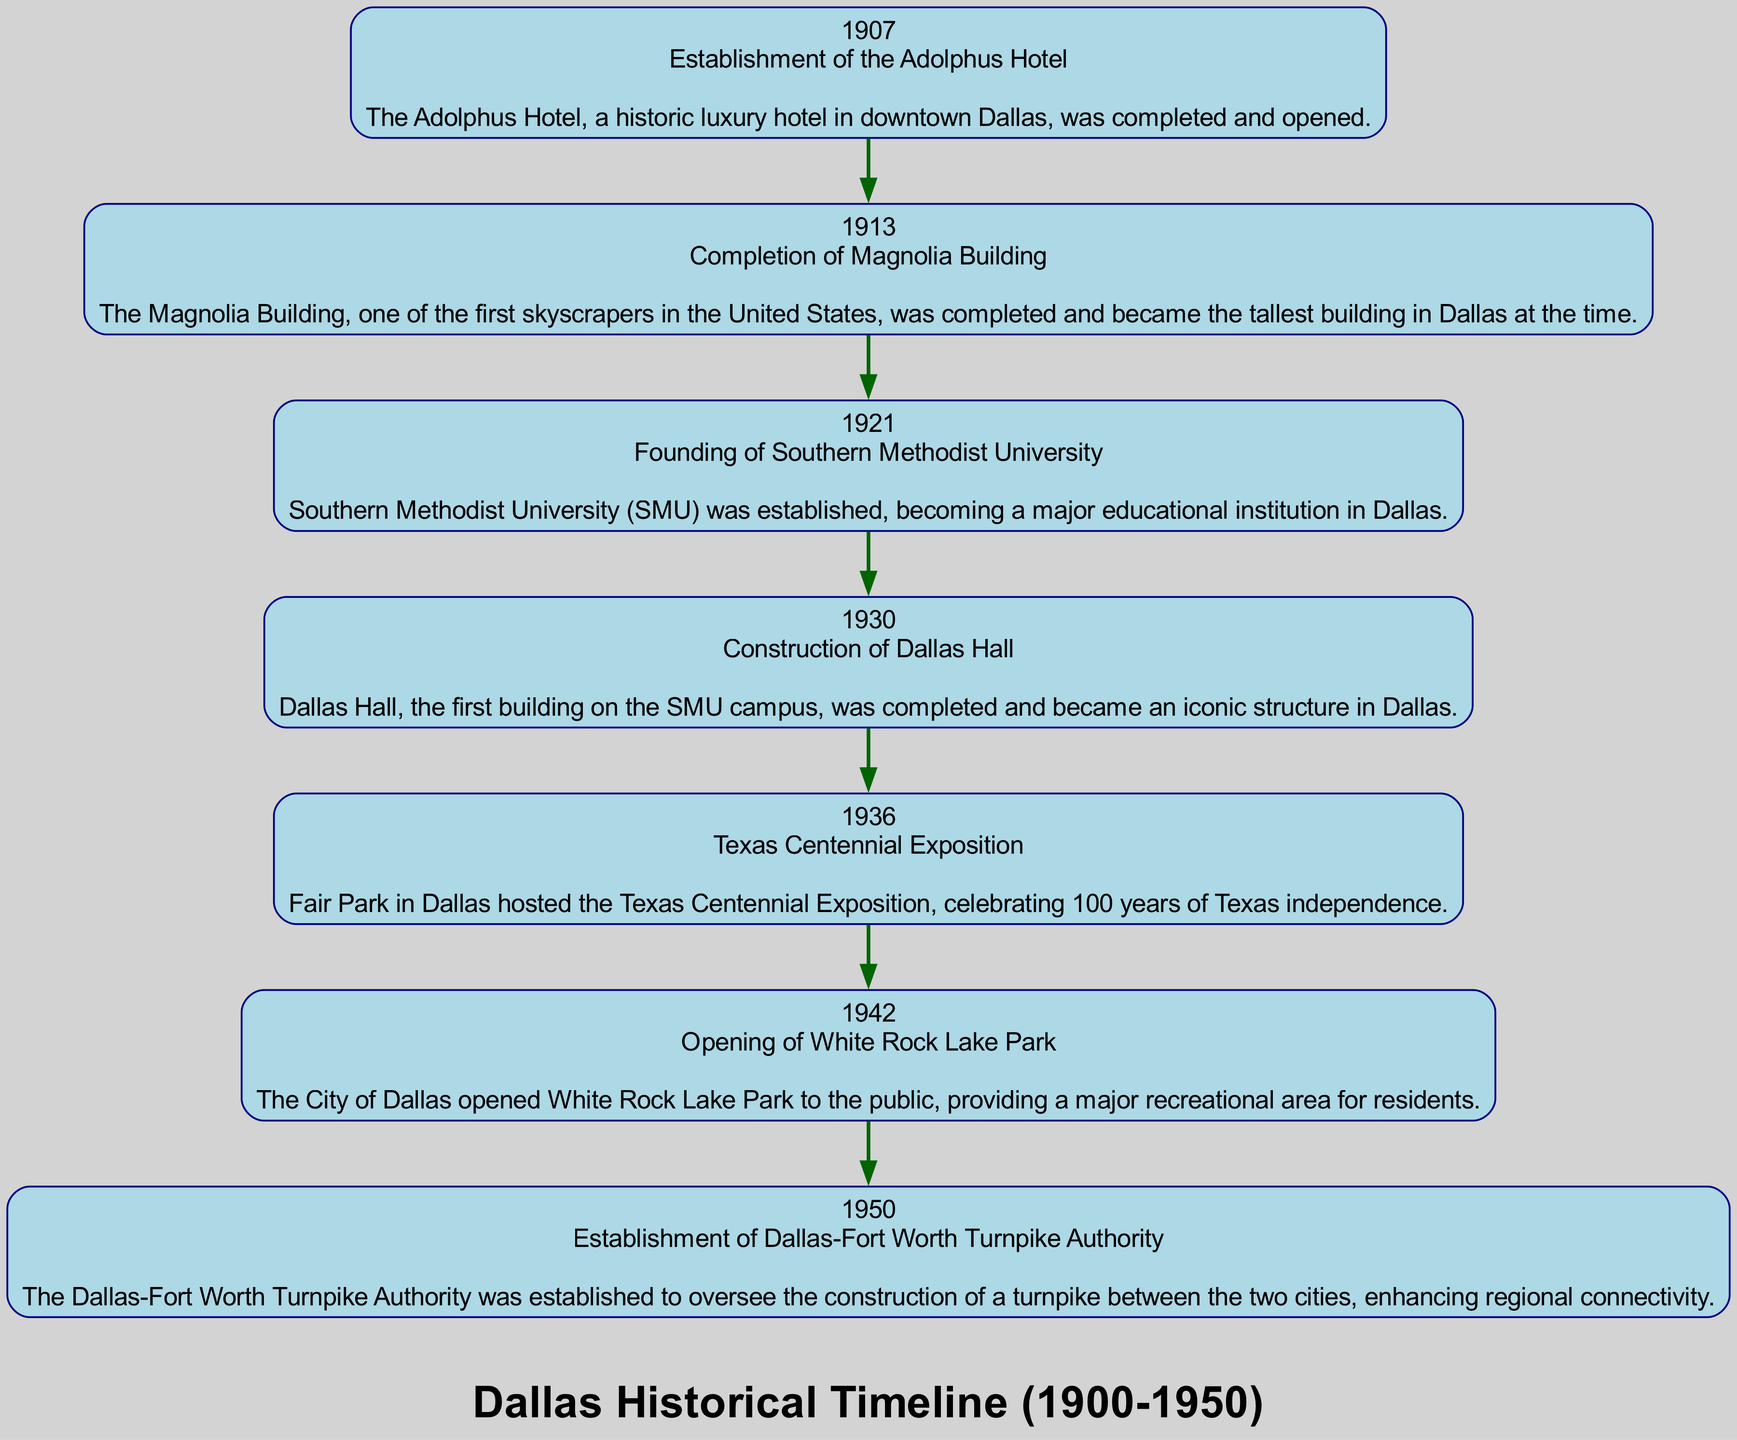What year was the Texas Centennial Exposition held? The diagram shows the event labeled "Texas Centennial Exposition" associated with the year 1936.
Answer: 1936 How many major historical events are listed in the timeline? By counting each of the events depicted in the diagram, I find there are seven distinct events presented.
Answer: 7 Which event occurred immediately after the completion of the Magnolia Building? The diagram shows that the completion of the Magnolia Building in 1913 is followed by the founding of Southern Methodist University in 1921.
Answer: Founding of Southern Methodist University What was the first event recorded in the timeline? The timeline starts with the establishment of the Adolphus Hotel in 1907, marked as the first event in the diagram.
Answer: Establishment of the Adolphus Hotel What do the edges in the diagram represent? The edges in the diagram represent the chronological relationships between the historical events listed, indicating the order they occurred.
Answer: Temporal relationships What year did the opening of White Rock Lake Park happen compared to the Texas Centennial Exposition? The diagram indicates White Rock Lake Park opened in 1942, which is six years after the Texas Centennial Exposition in 1936.
Answer: Six years Which landmark became the tallest building in Dallas during the timeline? The diagram highlights the completion of the Magnolia Building in 1913, marking it as the tallest building in Dallas at that time.
Answer: Magnolia Building What does the label of the diagram indicate about the scope of the events? The label of the diagram states "Dallas Historical Timeline (1900-1950)," indicating the temporal range of events covered.
Answer: 1900-1950 Which major educational institution was established in 1921? The event in the diagram for 1921 is the founding of Southern Methodist University, clearly indicating its establishment that year.
Answer: Southern Methodist University 